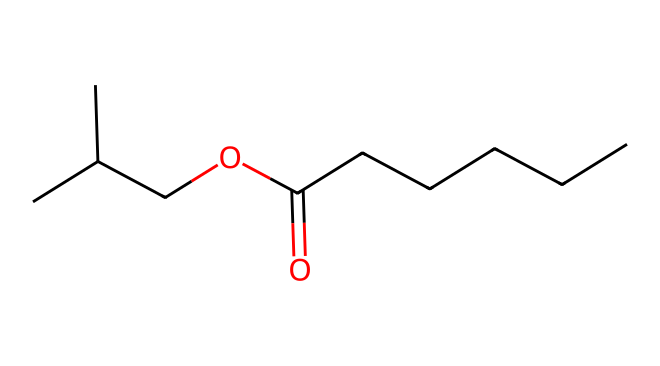What is the chemical family of this compound? This compound belongs to the ester family, which is identified by the presence of the ester functional group (-COO-) present in the chemical structure.
Answer: ester How many carbon atoms are in this chemical? By analyzing the SMILES representation, there are a total of 8 carbon atoms indicated by the 'C' characters in the structure.
Answer: eight Does this compound have any double bonds? The chemical structure includes a double bond between the carbonyl carbon (C=O), confirming that there is indeed a double bond in the compound.
Answer: yes What is the functional group present in this compound? The presence of the -COO- group identifies this chemical as an ester, which is characterized by this particular functional group.
Answer: -COO- What type of reaction is typically involved in forming this compound? Esters are commonly formed through esterification, which is a reaction between an alcohol and a carboxylic acid, producing an ester and water.
Answer: esterification What is the main characteristic smell associated with this compound? This compound provides a sweet, fruity aroma that is typically associated with pineapples, due to its specific ester structure.
Answer: pineapple aroma What kind of alcohol is included in this compound? The presence of the 'CC(C)' portion in the SMILES suggests a branched-chain alcohol structure, specifically isopropanol.
Answer: isopropanol 